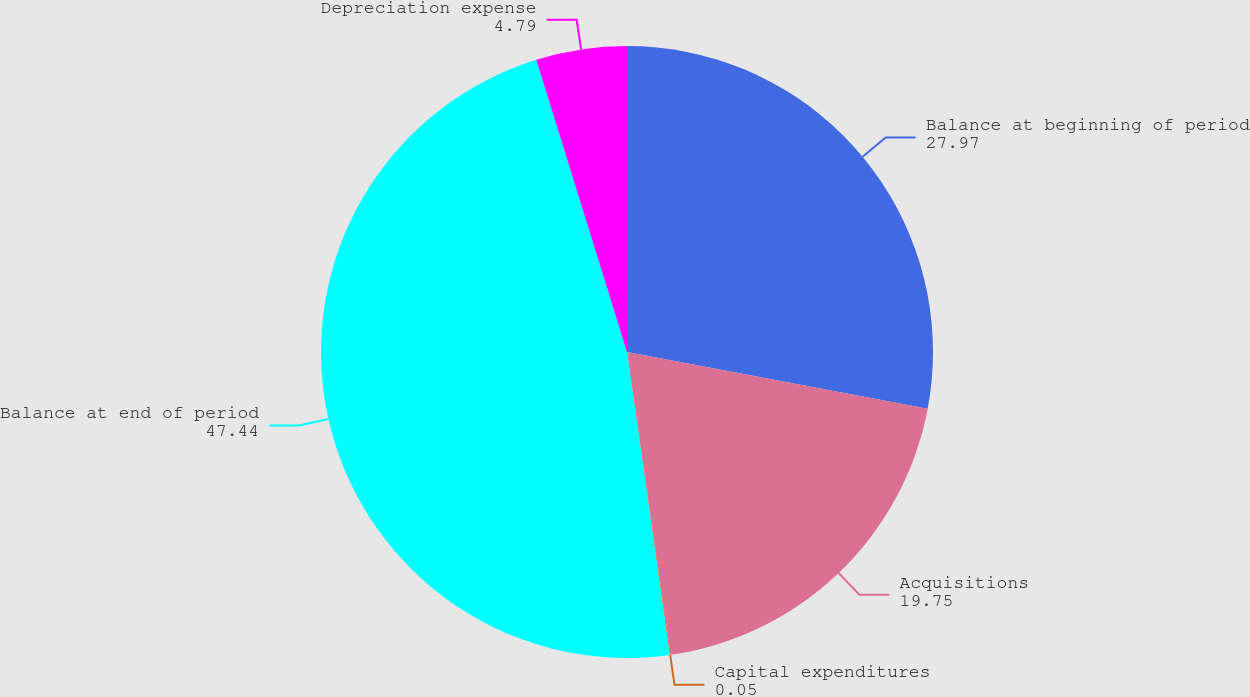<chart> <loc_0><loc_0><loc_500><loc_500><pie_chart><fcel>Balance at beginning of period<fcel>Acquisitions<fcel>Capital expenditures<fcel>Balance at end of period<fcel>Depreciation expense<nl><fcel>27.97%<fcel>19.75%<fcel>0.05%<fcel>47.44%<fcel>4.79%<nl></chart> 